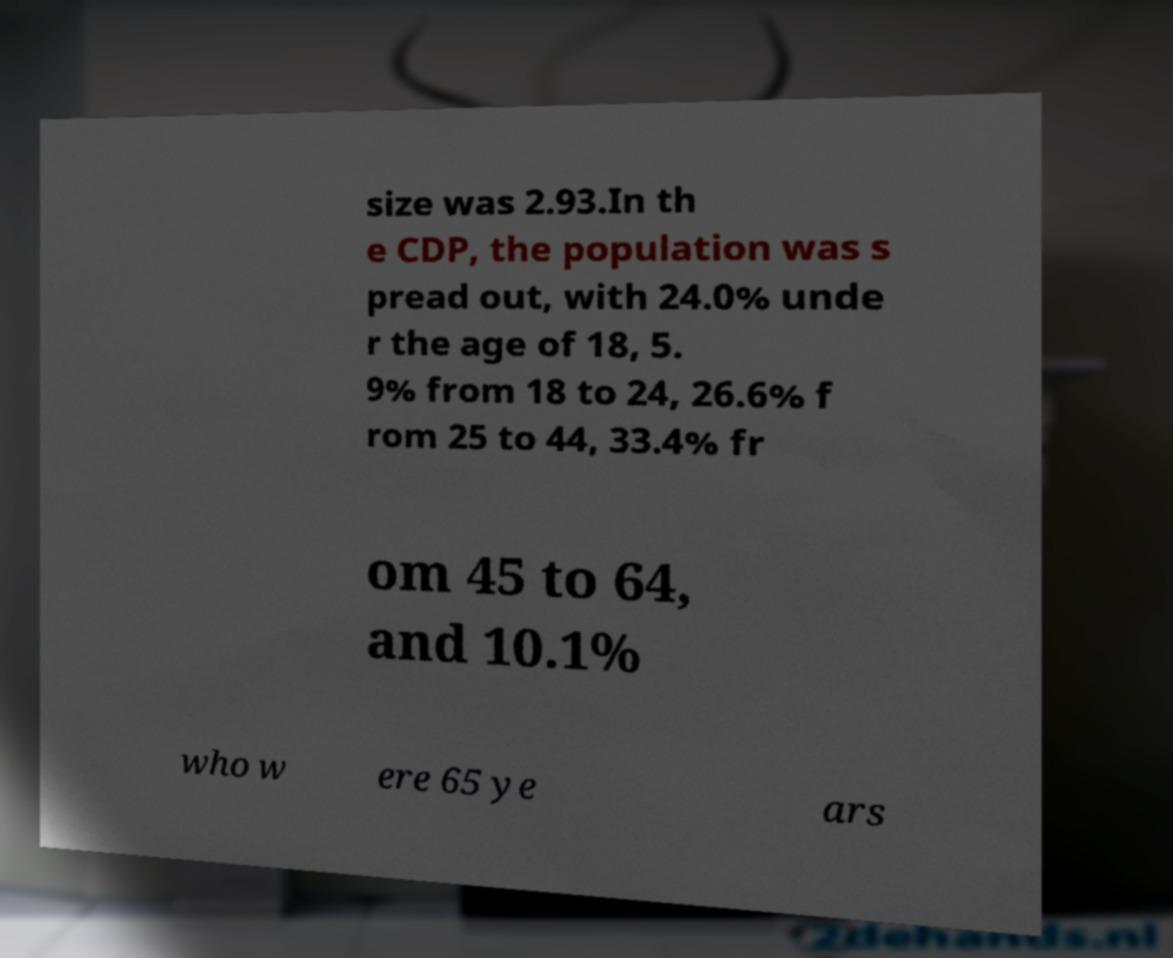Can you read and provide the text displayed in the image?This photo seems to have some interesting text. Can you extract and type it out for me? size was 2.93.In th e CDP, the population was s pread out, with 24.0% unde r the age of 18, 5. 9% from 18 to 24, 26.6% f rom 25 to 44, 33.4% fr om 45 to 64, and 10.1% who w ere 65 ye ars 